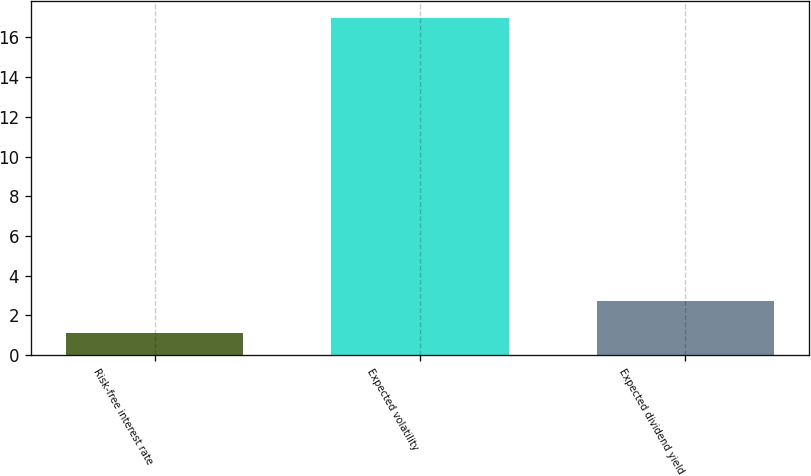Convert chart. <chart><loc_0><loc_0><loc_500><loc_500><bar_chart><fcel>Risk-free interest rate<fcel>Expected volatility<fcel>Expected dividend yield<nl><fcel>1.1<fcel>17<fcel>2.7<nl></chart> 